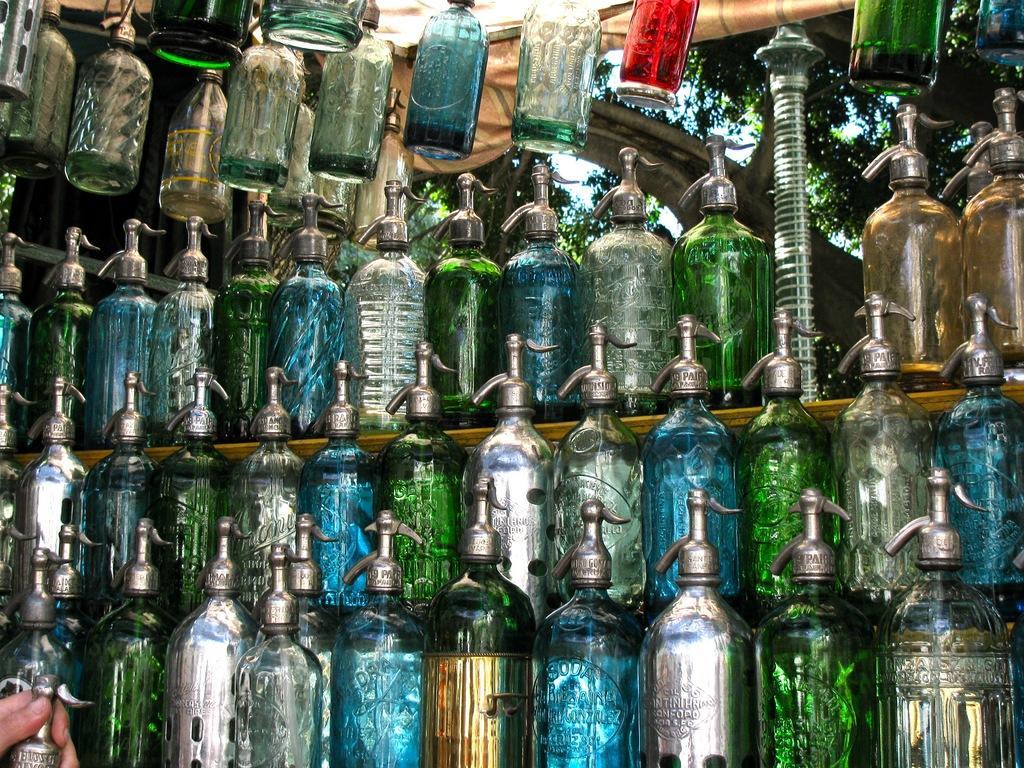In one or two sentences, can you explain what this image depicts? In this image I can see number of bottles. Here I can see a hand of a person. 